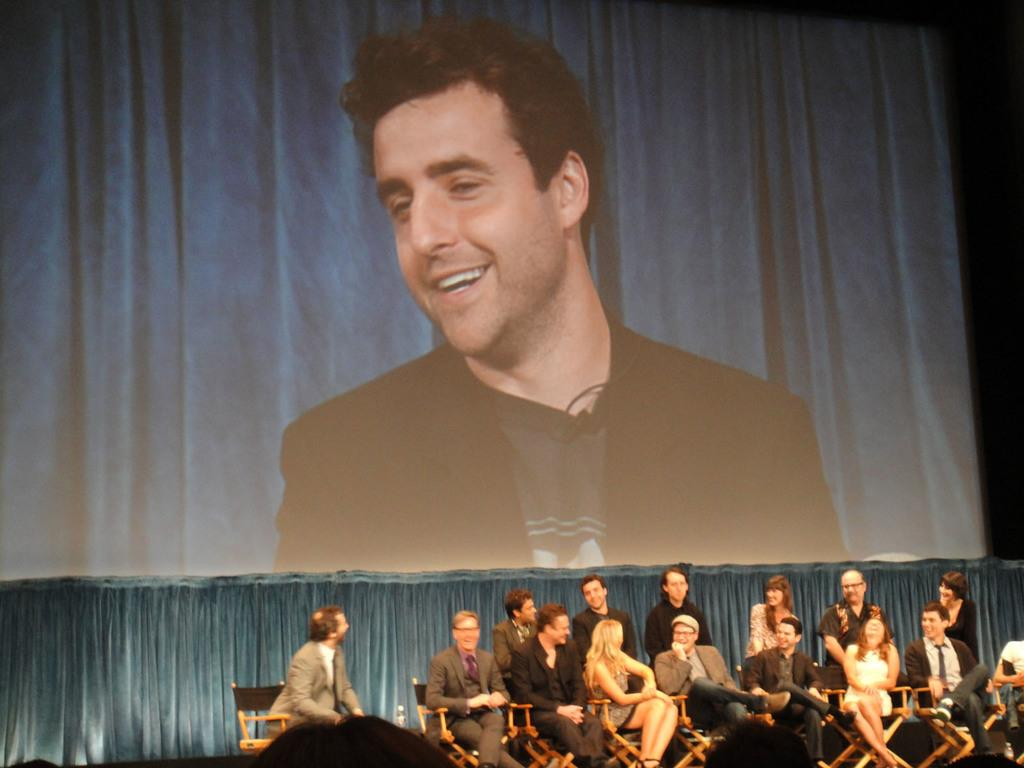Who or what can be seen in the image? There are people in the image. What are the people doing in the image? The people are sitting on chairs. What else is present in the image besides the people? There is a screen in the image. What is displayed on the screen? A person's picture is displayed on the screen. How many bushes are visible in the image? There are no bushes present in the image. What type of knot is being tied by the person in the image? There is no person tying a knot in the image; the people are sitting on chairs and a person's picture is displayed on the screen. 